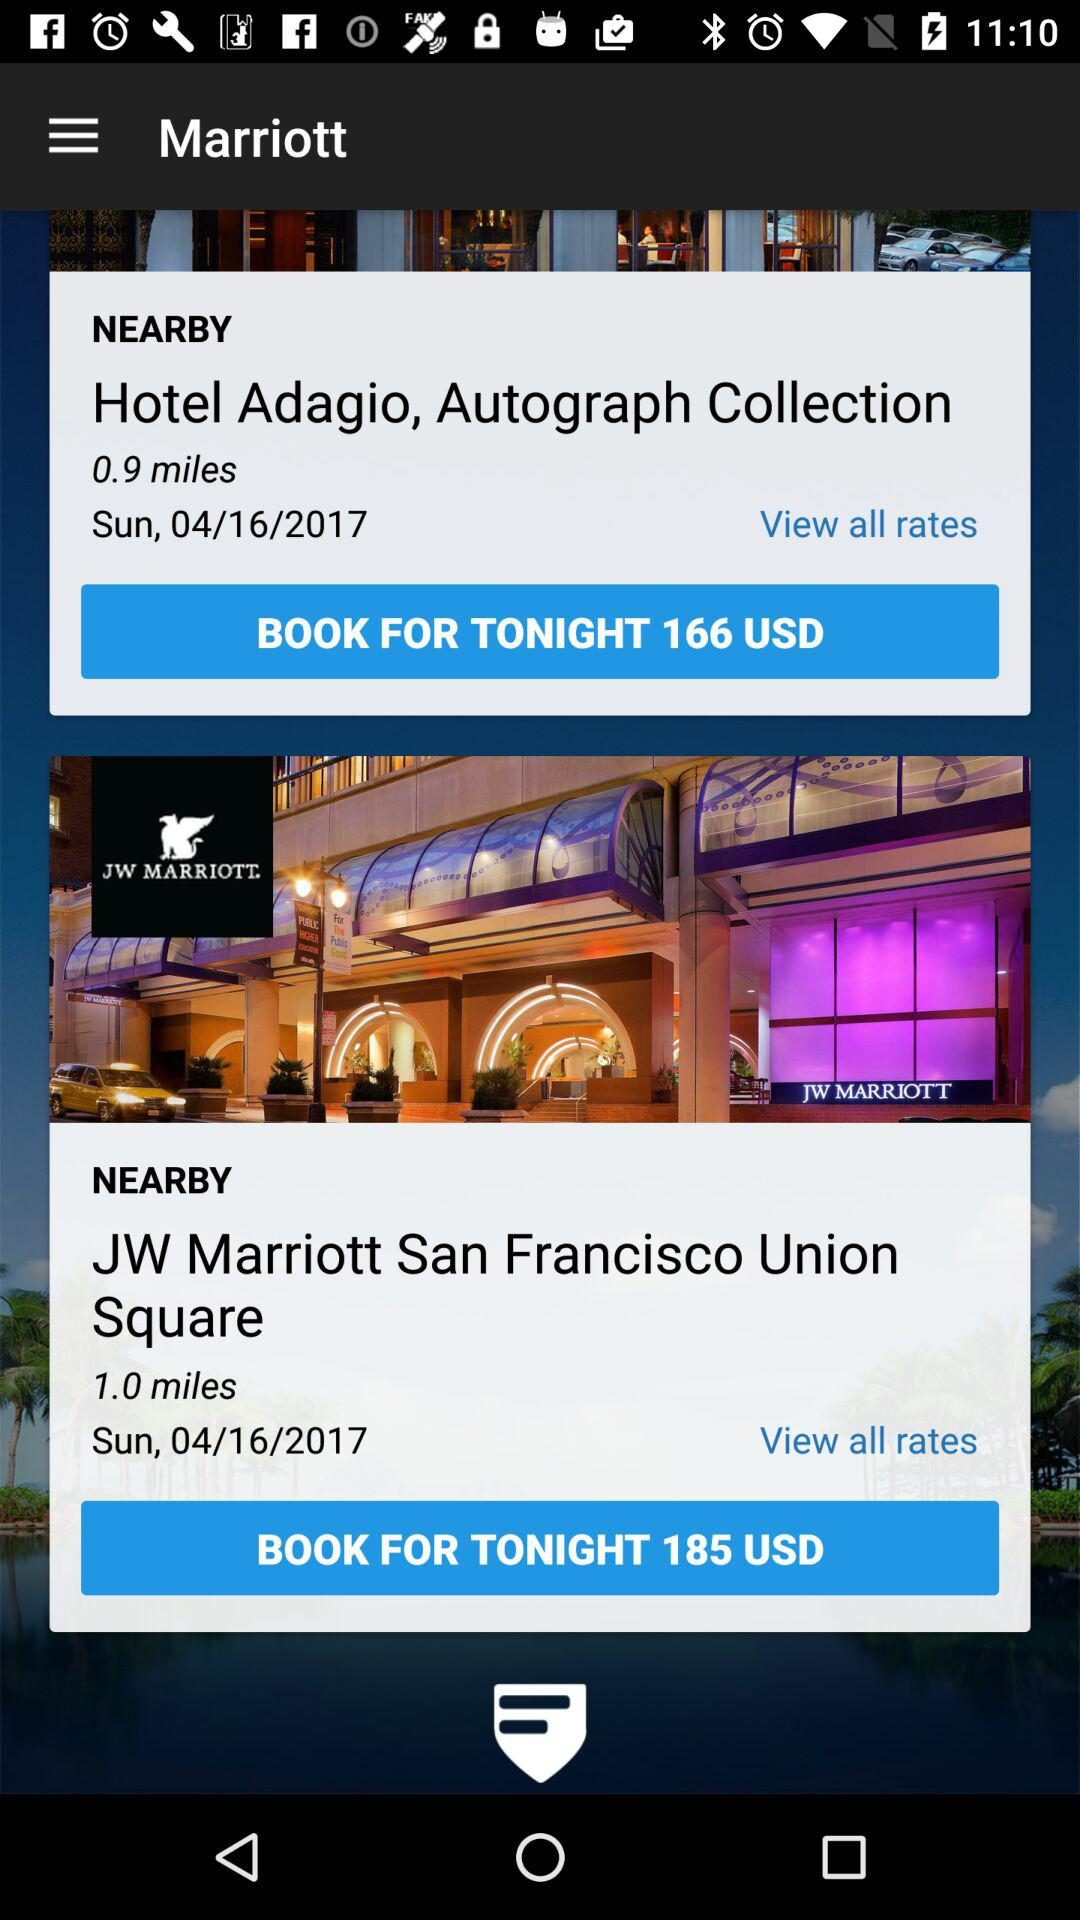What is the currency of a price? The currency is the USD. 